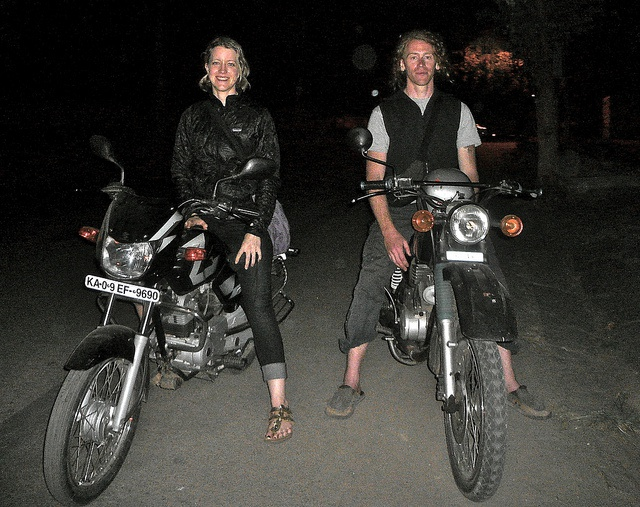Describe the objects in this image and their specific colors. I can see motorcycle in black, gray, darkgray, and lightgray tones, motorcycle in black, gray, darkgray, and white tones, people in black, gray, and lightpink tones, people in black, gray, and darkgray tones, and handbag in black and gray tones in this image. 